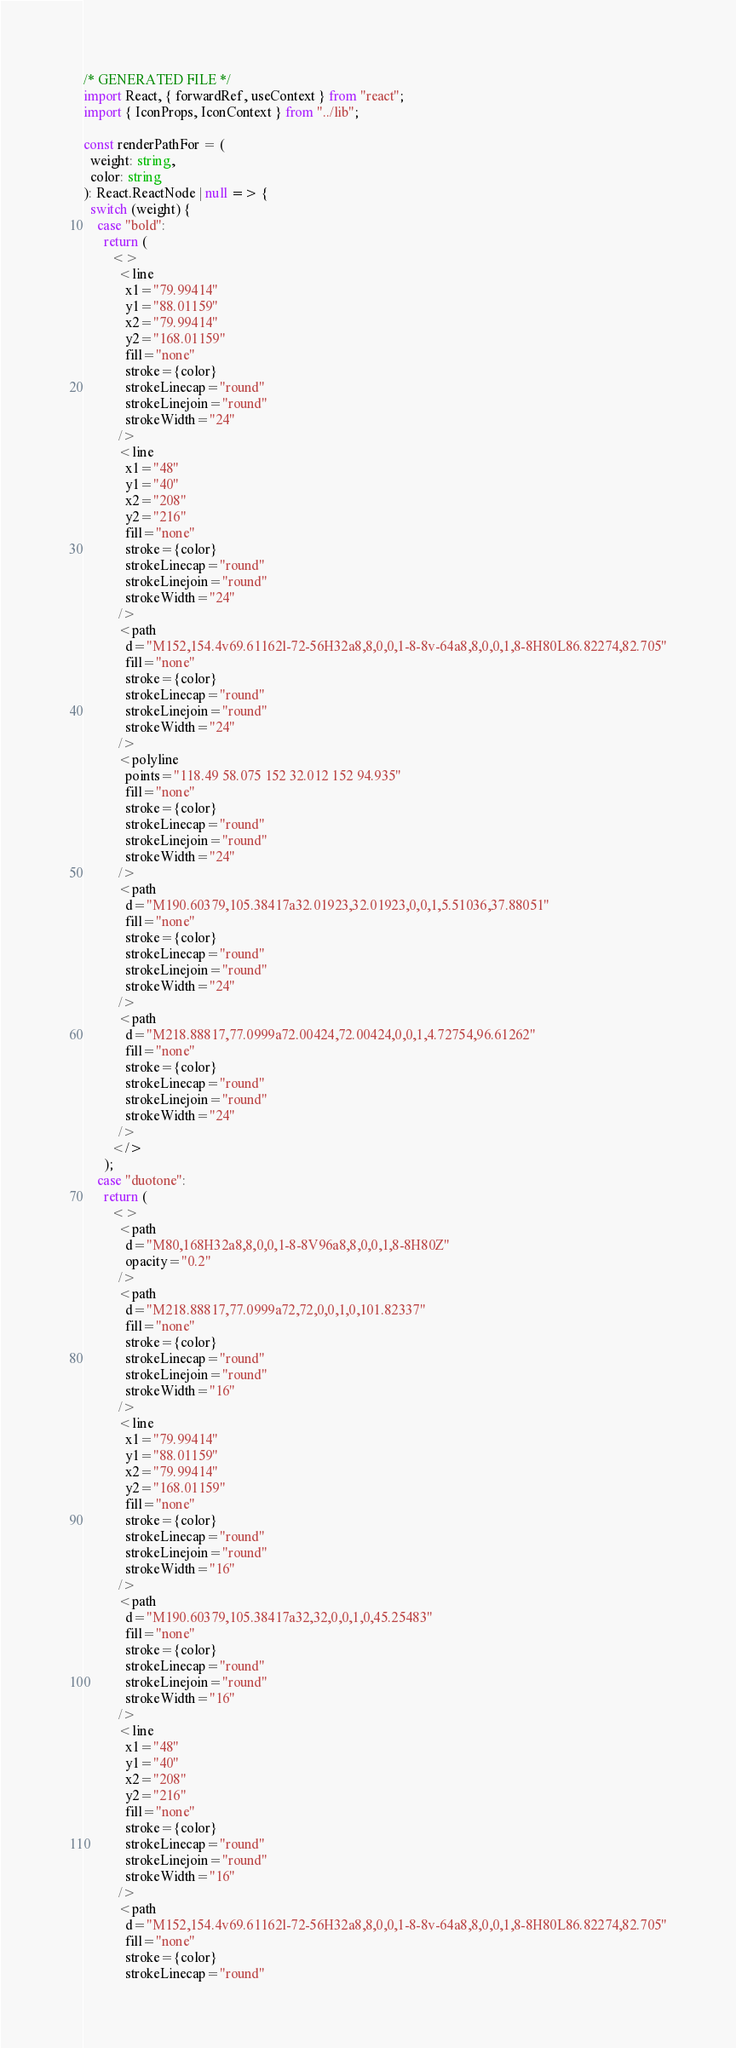<code> <loc_0><loc_0><loc_500><loc_500><_TypeScript_>/* GENERATED FILE */
import React, { forwardRef, useContext } from "react";
import { IconProps, IconContext } from "../lib";

const renderPathFor = (
  weight: string,
  color: string
): React.ReactNode | null => {
  switch (weight) {
    case "bold":
      return (
        <>
          <line
            x1="79.99414"
            y1="88.01159"
            x2="79.99414"
            y2="168.01159"
            fill="none"
            stroke={color}
            strokeLinecap="round"
            strokeLinejoin="round"
            strokeWidth="24"
          />
          <line
            x1="48"
            y1="40"
            x2="208"
            y2="216"
            fill="none"
            stroke={color}
            strokeLinecap="round"
            strokeLinejoin="round"
            strokeWidth="24"
          />
          <path
            d="M152,154.4v69.61162l-72-56H32a8,8,0,0,1-8-8v-64a8,8,0,0,1,8-8H80L86.82274,82.705"
            fill="none"
            stroke={color}
            strokeLinecap="round"
            strokeLinejoin="round"
            strokeWidth="24"
          />
          <polyline
            points="118.49 58.075 152 32.012 152 94.935"
            fill="none"
            stroke={color}
            strokeLinecap="round"
            strokeLinejoin="round"
            strokeWidth="24"
          />
          <path
            d="M190.60379,105.38417a32.01923,32.01923,0,0,1,5.51036,37.88051"
            fill="none"
            stroke={color}
            strokeLinecap="round"
            strokeLinejoin="round"
            strokeWidth="24"
          />
          <path
            d="M218.88817,77.0999a72.00424,72.00424,0,0,1,4.72754,96.61262"
            fill="none"
            stroke={color}
            strokeLinecap="round"
            strokeLinejoin="round"
            strokeWidth="24"
          />
        </>
      );
    case "duotone":
      return (
        <>
          <path
            d="M80,168H32a8,8,0,0,1-8-8V96a8,8,0,0,1,8-8H80Z"
            opacity="0.2"
          />
          <path
            d="M218.88817,77.0999a72,72,0,0,1,0,101.82337"
            fill="none"
            stroke={color}
            strokeLinecap="round"
            strokeLinejoin="round"
            strokeWidth="16"
          />
          <line
            x1="79.99414"
            y1="88.01159"
            x2="79.99414"
            y2="168.01159"
            fill="none"
            stroke={color}
            strokeLinecap="round"
            strokeLinejoin="round"
            strokeWidth="16"
          />
          <path
            d="M190.60379,105.38417a32,32,0,0,1,0,45.25483"
            fill="none"
            stroke={color}
            strokeLinecap="round"
            strokeLinejoin="round"
            strokeWidth="16"
          />
          <line
            x1="48"
            y1="40"
            x2="208"
            y2="216"
            fill="none"
            stroke={color}
            strokeLinecap="round"
            strokeLinejoin="round"
            strokeWidth="16"
          />
          <path
            d="M152,154.4v69.61162l-72-56H32a8,8,0,0,1-8-8v-64a8,8,0,0,1,8-8H80L86.82274,82.705"
            fill="none"
            stroke={color}
            strokeLinecap="round"</code> 